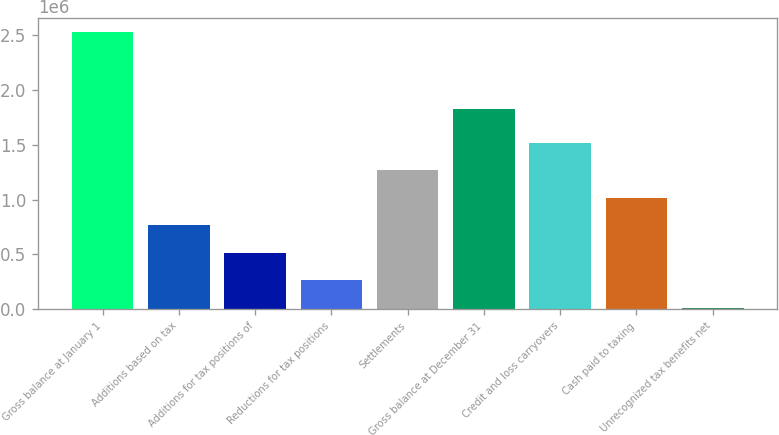Convert chart. <chart><loc_0><loc_0><loc_500><loc_500><bar_chart><fcel>Gross balance at January 1<fcel>Additions based on tax<fcel>Additions for tax positions of<fcel>Reductions for tax positions<fcel>Settlements<fcel>Gross balance at December 31<fcel>Credit and loss carryovers<fcel>Cash paid to taxing<fcel>Unrecognized tax benefits net<nl><fcel>2.52379e+06<fcel>765337<fcel>514129<fcel>262921<fcel>1.26775e+06<fcel>1.82545e+06<fcel>1.51896e+06<fcel>1.01655e+06<fcel>11713<nl></chart> 